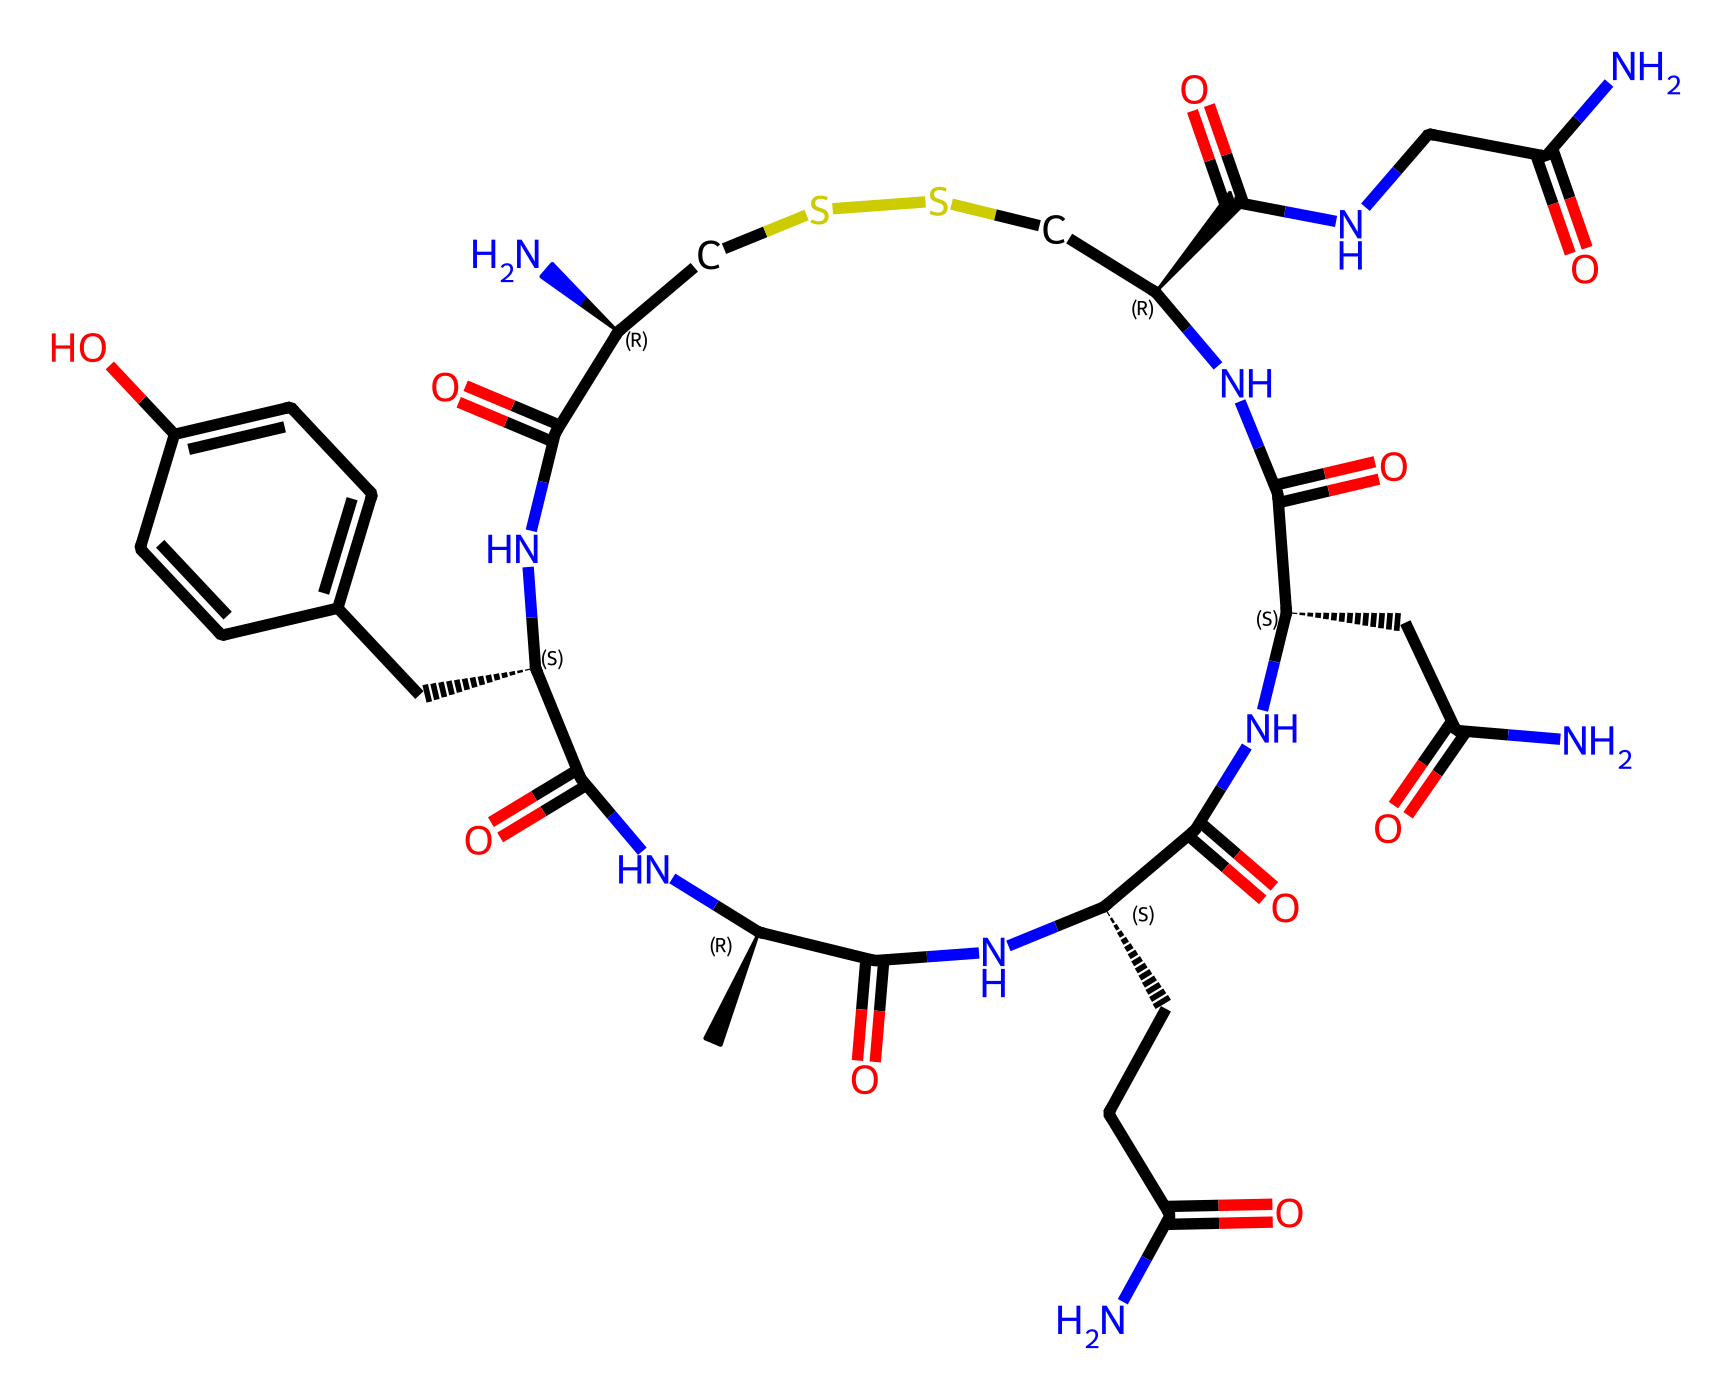What is the molecular formula of oxytocin? The molecular formula can be derived from the SMILES representation by counting all the carbon, hydrogen, nitrogen, oxygen, and sulfur atoms present. In the given SMILES, there are 21 carbon atoms, 29 hydrogen atoms, 5 nitrogen atoms, 3 oxygen atoms, and 1 sulfur atom, leading to the molecular formula C21H29N5O3S.
Answer: C21H29N5O3S How many rings are present in the structure of oxytocin? To determine the number of rings, we can analyze the SMILES and observe the cyclic structures indicated by the numbers attached to the atoms. The core structure shows that there are two ring systems present.
Answer: 2 What type of bonds are primarily present within the oxytocin structure? By examining the SMILES, we can identify that oxytocin mainly contains peptide bonds (between nitrogen and carbon) and disulfide bonds (indicated by "SS"). The prevalence of these bonds shows that it is a peptide hormone.
Answer: peptide and disulfide Which atoms in this hormone are responsible for its function as a bonding hormone? The bonding function of oxytocin is primarily associated with the amino group (-NH), as they play a crucial role in forming peptide bonds and hydrogen bonding in biological systems, facilitating inter- and intra-molecular interactions.
Answer: nitrogen What is the total number of amino acids represented in the oxytocin structure? From the analysis of the structure, particularly looking at the peptide bonds, one can identify that oxytocin is composed of 9 amino acids which contribute to its biological activity as a hormone.
Answer: 9 Which elements in the structure can form hydrogen bonds? Typically, hydrogen bonds are formed between hydrogen atoms covalently bonded to electronegative atoms like nitrogen and oxygen in the molecule. By examining the SMILES, we identify nitrogen and oxygen atoms that can participate in hydrogen bonding.
Answer: nitrogen and oxygen 